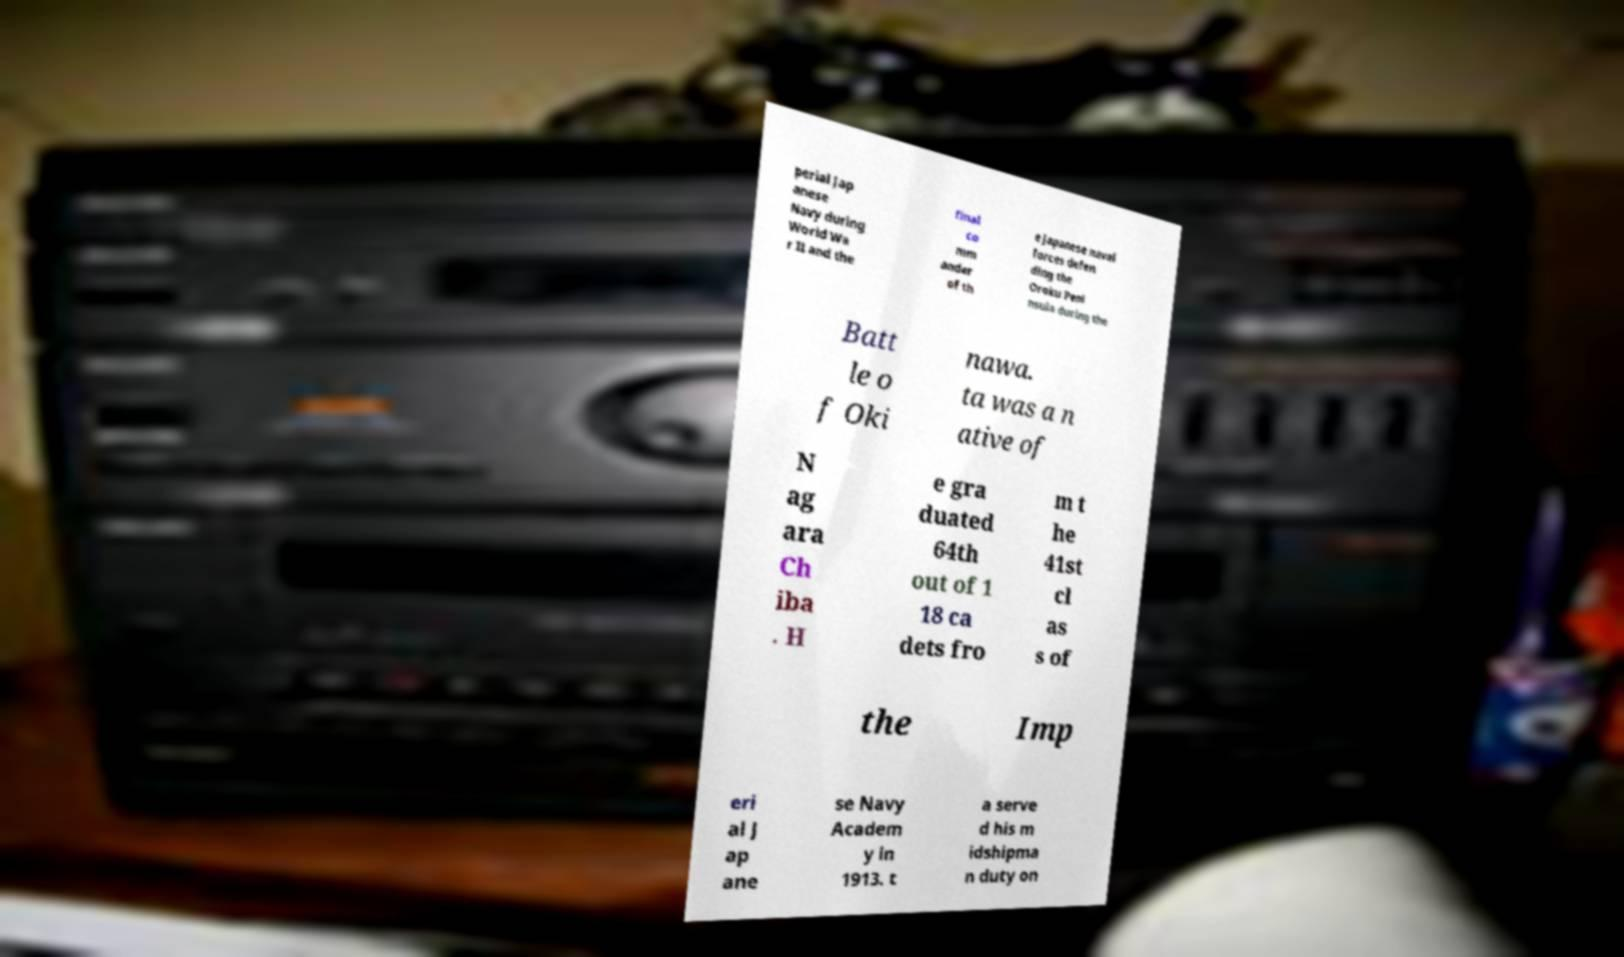Please identify and transcribe the text found in this image. perial Jap anese Navy during World Wa r II and the final co mm ander of th e Japanese naval forces defen ding the Oroku Peni nsula during the Batt le o f Oki nawa. ta was a n ative of N ag ara Ch iba . H e gra duated 64th out of 1 18 ca dets fro m t he 41st cl as s of the Imp eri al J ap ane se Navy Academ y in 1913. t a serve d his m idshipma n duty on 